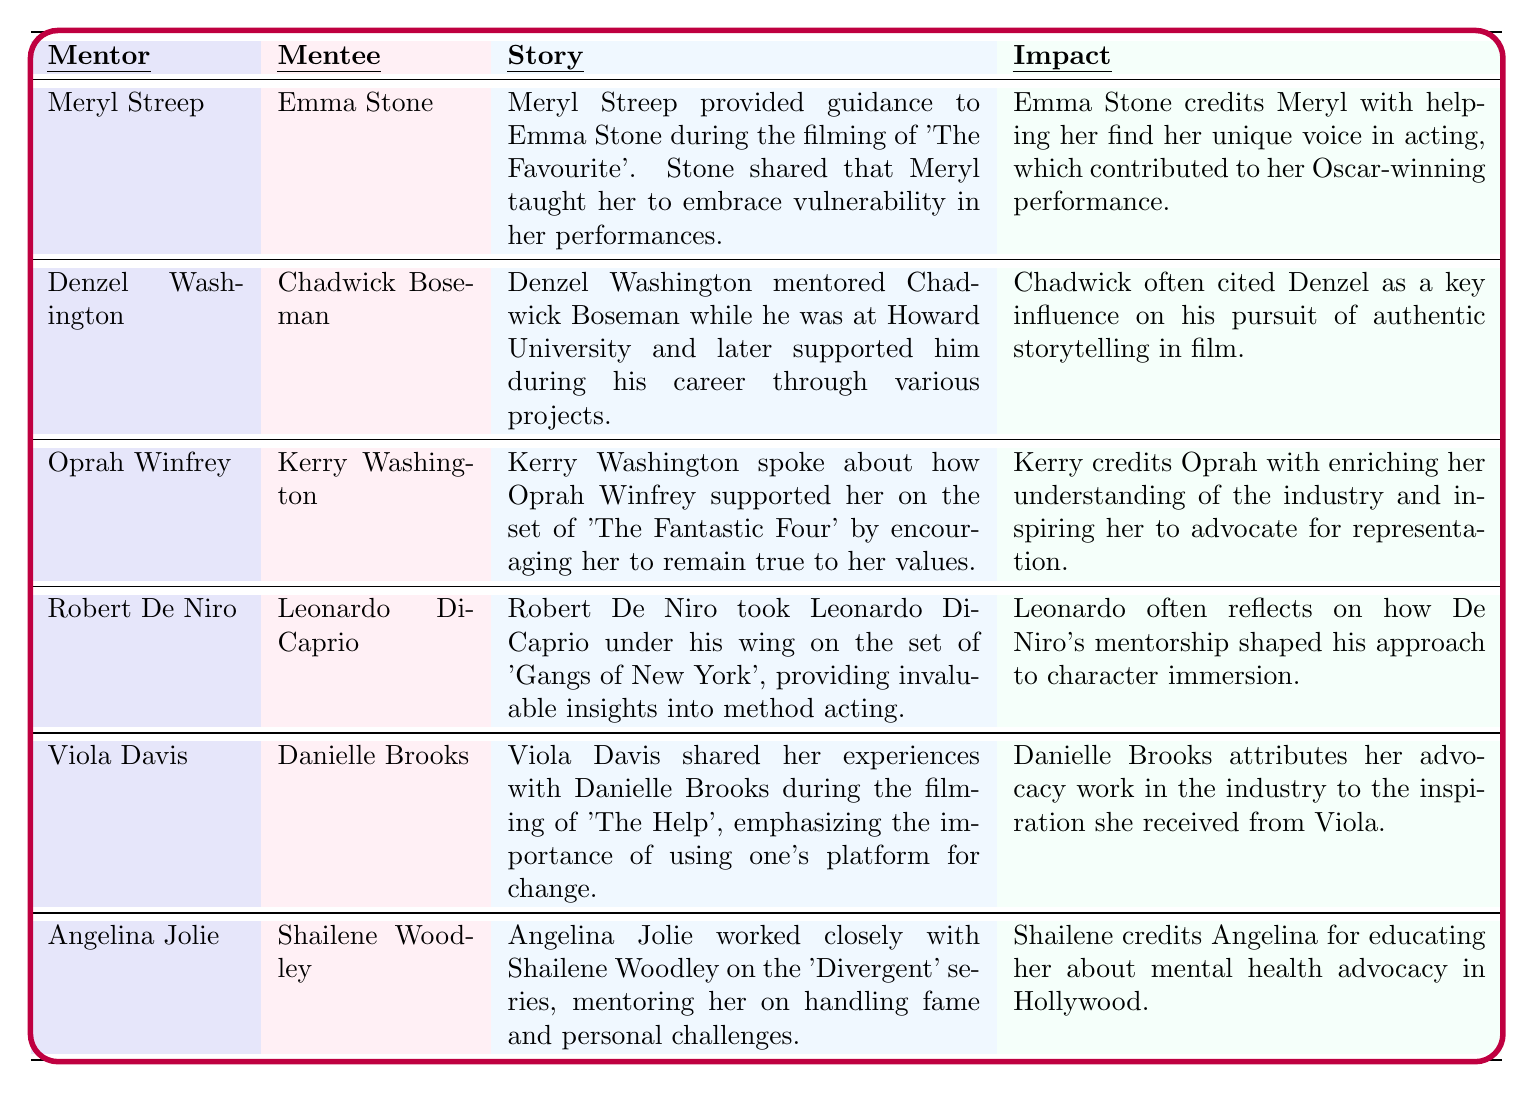What is the story shared by Emma Stone's mentor? According to the table, Meryl Streep provided guidance to Emma Stone during the filming of 'The Favourite', teaching her to embrace vulnerability in her performances.
Answer: Meryl taught Emma to embrace vulnerability Who was mentored by Denzel Washington? The table indicates that Chadwick Boseman was the mentee of Denzel Washington while at Howard University and throughout his career.
Answer: Chadwick Boseman Which mentor emphasized the importance of using one's platform for change? From the table, it is clear that Viola Davis emphasized the importance of using one's platform for change during her mentorship with Danielle Brooks.
Answer: Viola Davis What impact did Meryl Streep have on Emma Stone's acting? Emma Stone credits Meryl Streep with helping her find her unique voice in acting, contributing to her Oscar-winning performance.
Answer: Helped Emma find her unique voice How many mentors mentioned in the table worked in the film 'The Help'? The table lists only Viola Davis as a mentor associated with the film 'The Help', as she shared her experiences with Danielle Brooks during its filming.
Answer: One mentor Did Oprah Winfrey inspire Kerry Washington to advocate for representation? Yes, the table states that Kerry credits Oprah with enriching her understanding of the industry and inspiring her advocacy for representation.
Answer: Yes Which mentor mentioned educating their mentee about mental health advocacy? According to the table, Angelina Jolie mentioned educating Shailene Woodley about mental health advocacy during their mentorship on the 'Divergent' series.
Answer: Angelina Jolie Who had the greatest impact according to Chadwick Boseman? The table notes that Chadwick Boseman often cited Denzel Washington as a key influence on his pursuit of authentic storytelling in film, indicating his significant impact.
Answer: Denzel Washington Compare the impacts of Meryl Streep and Oprah Winfrey's mentorships. Meryl Streep helped Emma Stone find her unique voice in acting, which led to an Oscar win, while Oprah Winfrey inspired Kerry Washington to advocate for representation, enriching her industry understanding. Both had profound impacts but in different areas of acting.
Answer: Different areas; unique voice vs. advocacy Which mentor took Leonardo DiCaprio under his wing on the set of 'Gangs of New York'? The table states that Robert De Niro mentored Leonardo DiCaprio on the set of 'Gangs of New York', providing insights into method acting.
Answer: Robert De Niro 